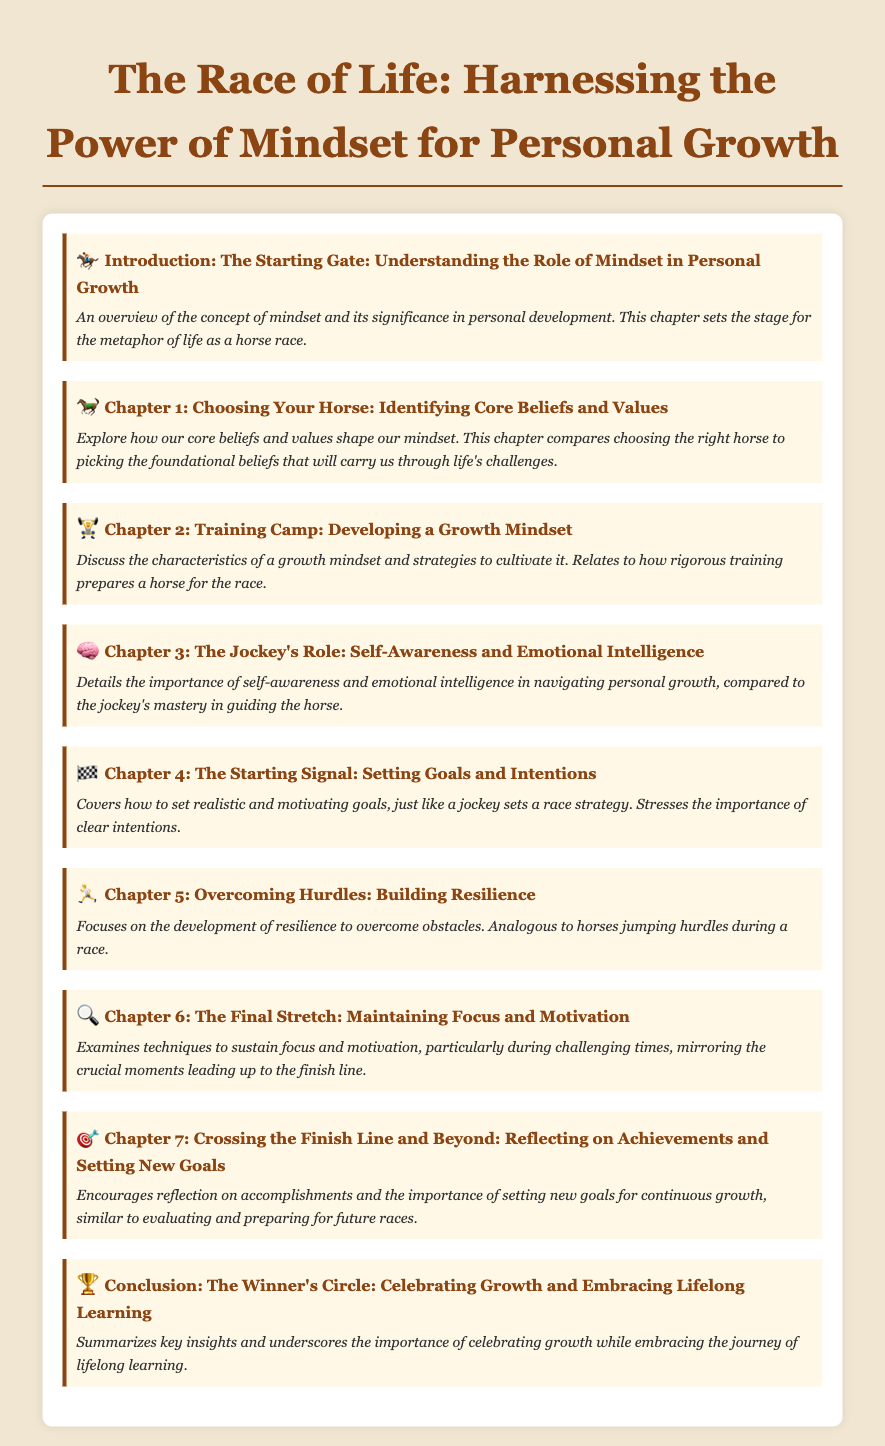What is the title of the document? The title is found at the top of the Table of Contents.
Answer: The Race of Life: Harnessing the Power of Mindset for Personal Growth What chapter discusses self-awareness and emotional intelligence? This is found under the chapter titles.
Answer: Chapter 3: The Jockey's Role: Self-Awareness and Emotional Intelligence How many chapters are in the document? Count the chapters listed in the Table of Contents.
Answer: 7 What metaphor is used to describe personal growth? The metaphor is mentioned in the introduction and is related to the overall theme.
Answer: Horse race Which chapter focuses on resilience? This is identified by the chapter title related to overcoming challenges.
Answer: Chapter 5: Overcoming Hurdles: Building Resilience What is the last chapter about? The content of the last chapter is summarized in the title and description.
Answer: Reflecting on Achievements and Setting New Goals What symbol precedes the conclusion chapter? The symbol indicates the chapter title that corresponds to the conclusion.
Answer: Trophy In which chapter are goals and intentions discussed? The chapter title contains key terms related to goal-setting.
Answer: Chapter 4: The Starting Signal: Setting Goals and Intentions 